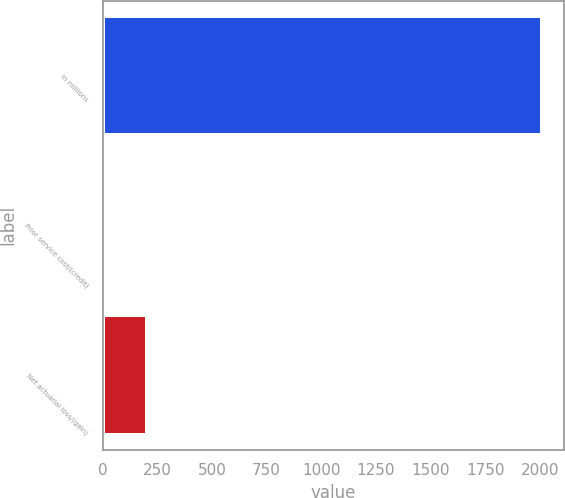<chart> <loc_0><loc_0><loc_500><loc_500><bar_chart><fcel>in millions<fcel>Prior service cost/(credit)<fcel>Net actuarial loss/(gain)<nl><fcel>2009<fcel>0.4<fcel>201.26<nl></chart> 